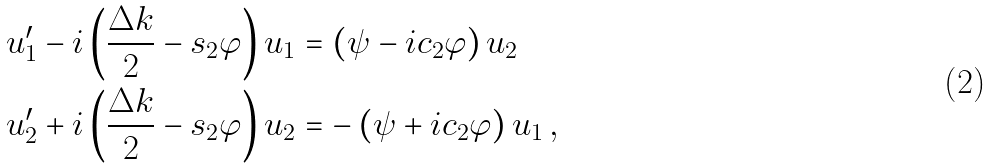<formula> <loc_0><loc_0><loc_500><loc_500>u _ { 1 } ^ { \prime } - i \left ( \frac { \Delta k } { 2 } - s _ { 2 } \varphi \right ) u _ { 1 } & = \left ( \psi - i c _ { 2 } \varphi \right ) u _ { 2 } \\ u _ { 2 } ^ { \prime } + i \left ( \frac { \Delta k } { 2 } - s _ { 2 } \varphi \right ) u _ { 2 } & = - \left ( \psi + i c _ { 2 } \varphi \right ) u _ { 1 } \, ,</formula> 